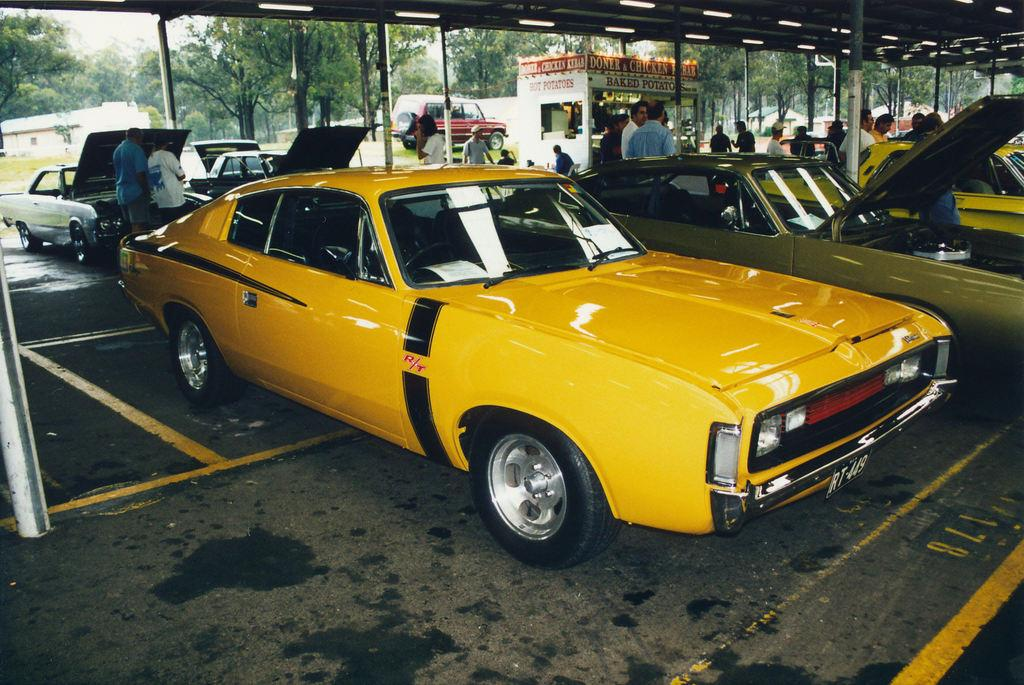<image>
Provide a brief description of the given image. A yellow car is parked at a car show in front of a hot potato bar sales wagon. 